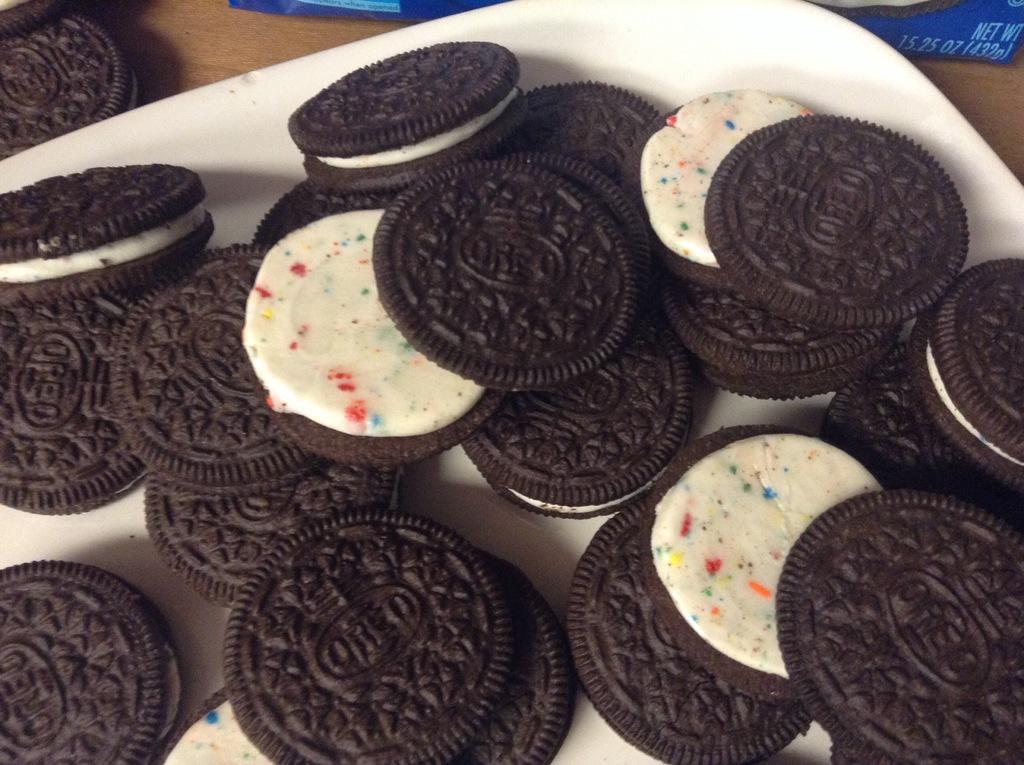Could you give a brief overview of what you see in this image? As we can see in the image, there are few cream biscuits. The biscuits are in brown color and the cream is in white color. The biscuits are kept on the plate. The plate is on table. 